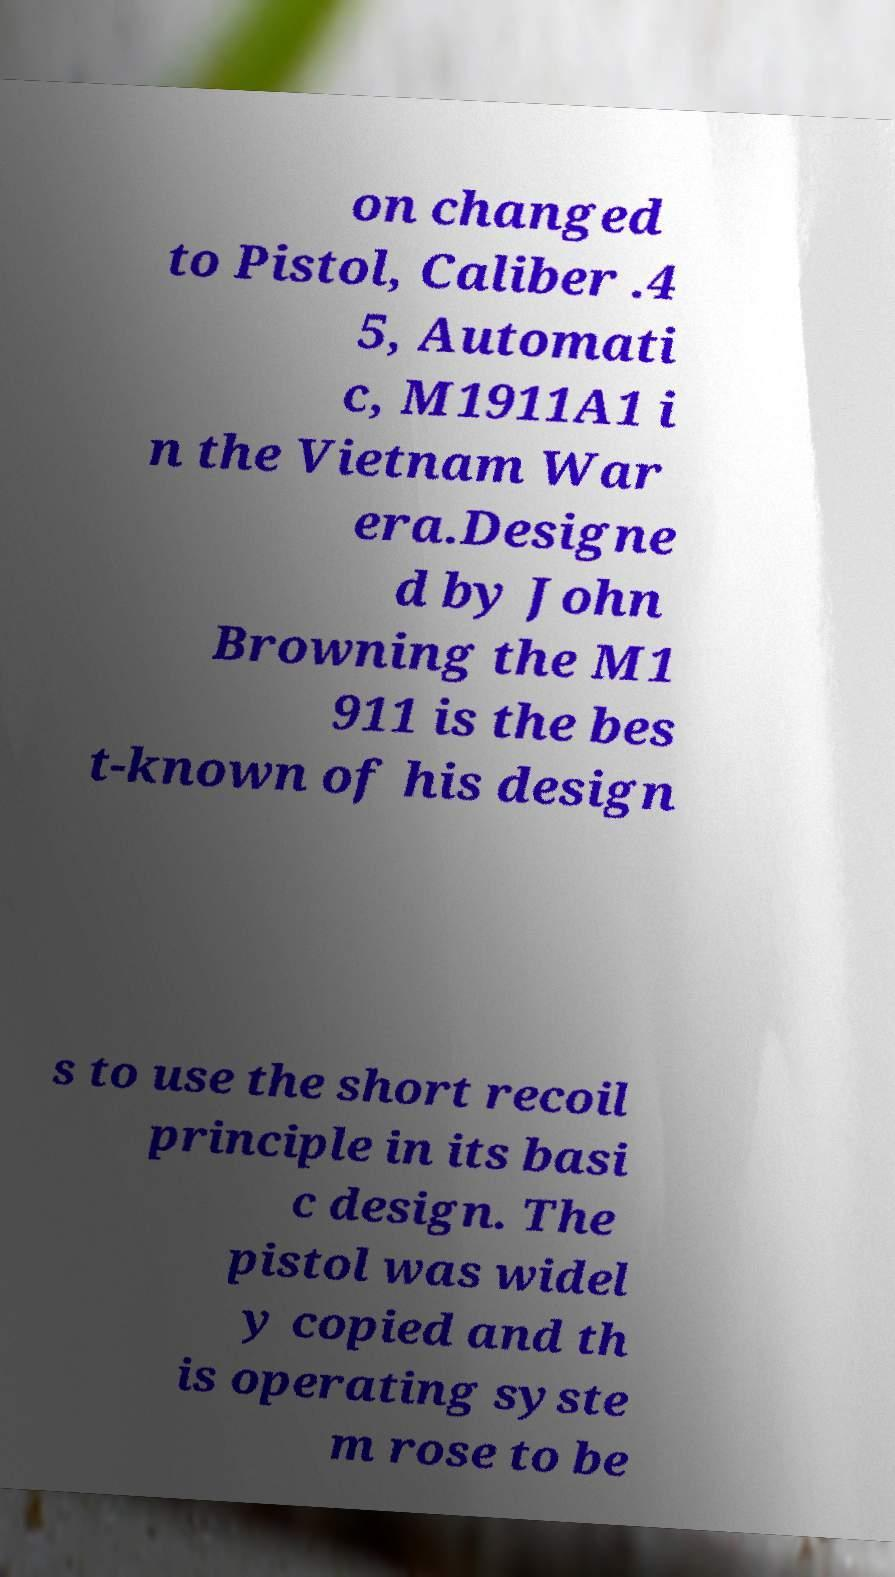I need the written content from this picture converted into text. Can you do that? on changed to Pistol, Caliber .4 5, Automati c, M1911A1 i n the Vietnam War era.Designe d by John Browning the M1 911 is the bes t-known of his design s to use the short recoil principle in its basi c design. The pistol was widel y copied and th is operating syste m rose to be 